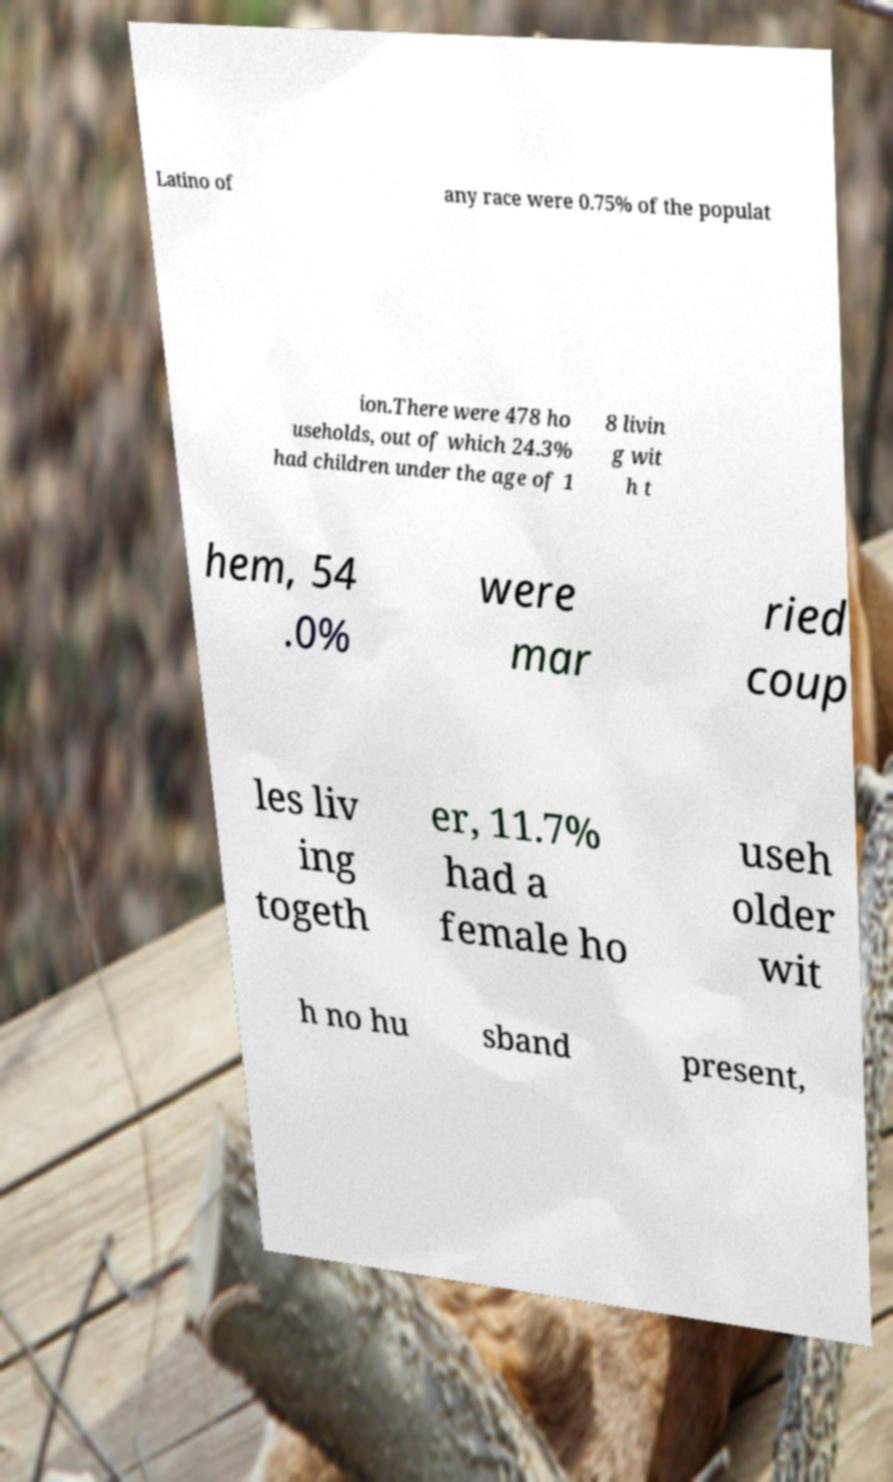What messages or text are displayed in this image? I need them in a readable, typed format. Latino of any race were 0.75% of the populat ion.There were 478 ho useholds, out of which 24.3% had children under the age of 1 8 livin g wit h t hem, 54 .0% were mar ried coup les liv ing togeth er, 11.7% had a female ho useh older wit h no hu sband present, 